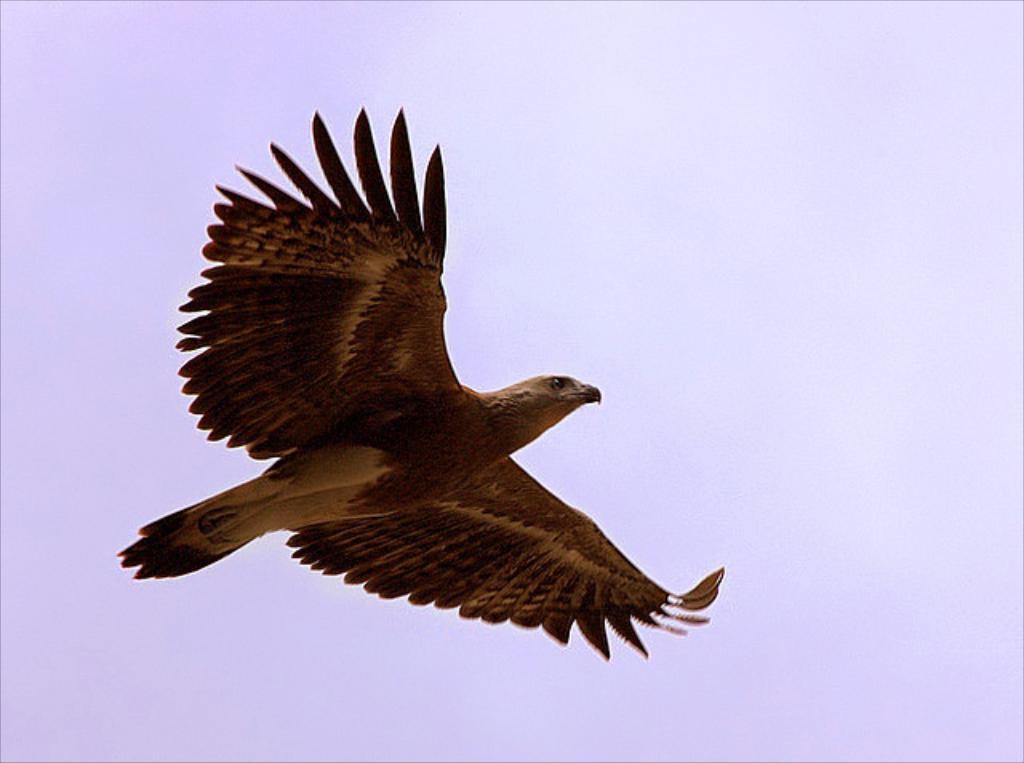What type of animal can be seen in the image? There is a bird in the image. What is the bird doing in the image? The bird is flying. What type of cub can be seen playing with the bird in the image? There is no cub present in the image, and the bird is flying, not playing with any other animals. 